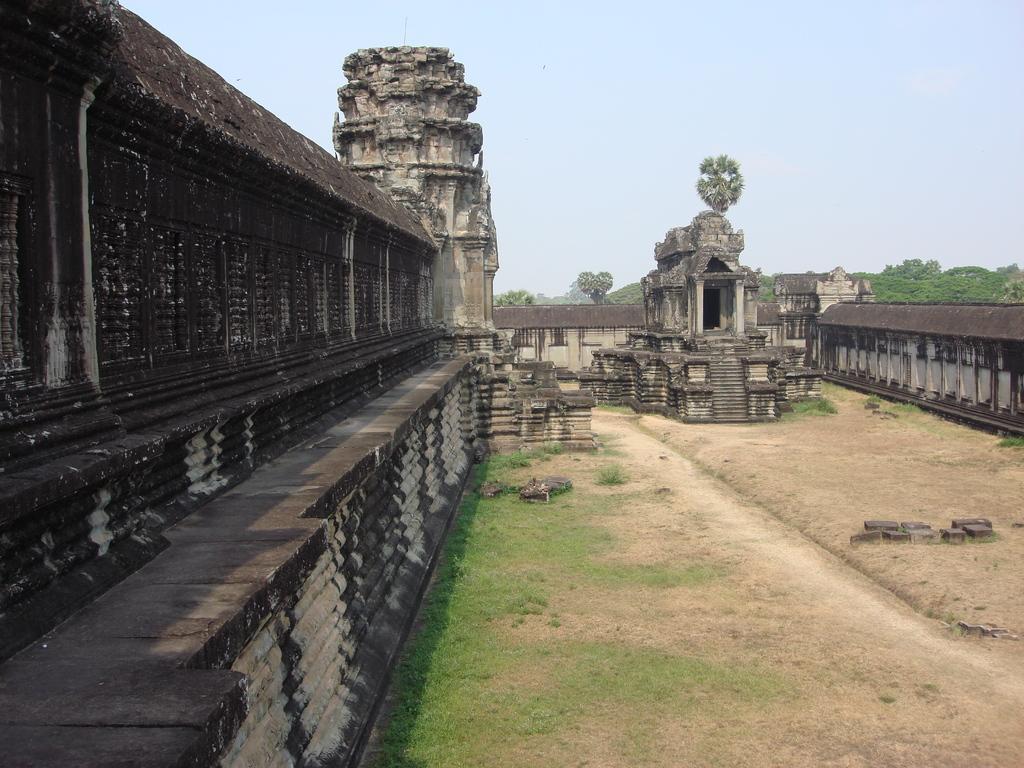In one or two sentences, can you explain what this image depicts? In this picture we can see grass at the bottom, it looks like a temple in the middle, on the right side there is a wall, in the background we can see trees, there is the sky at the top of the picture. 